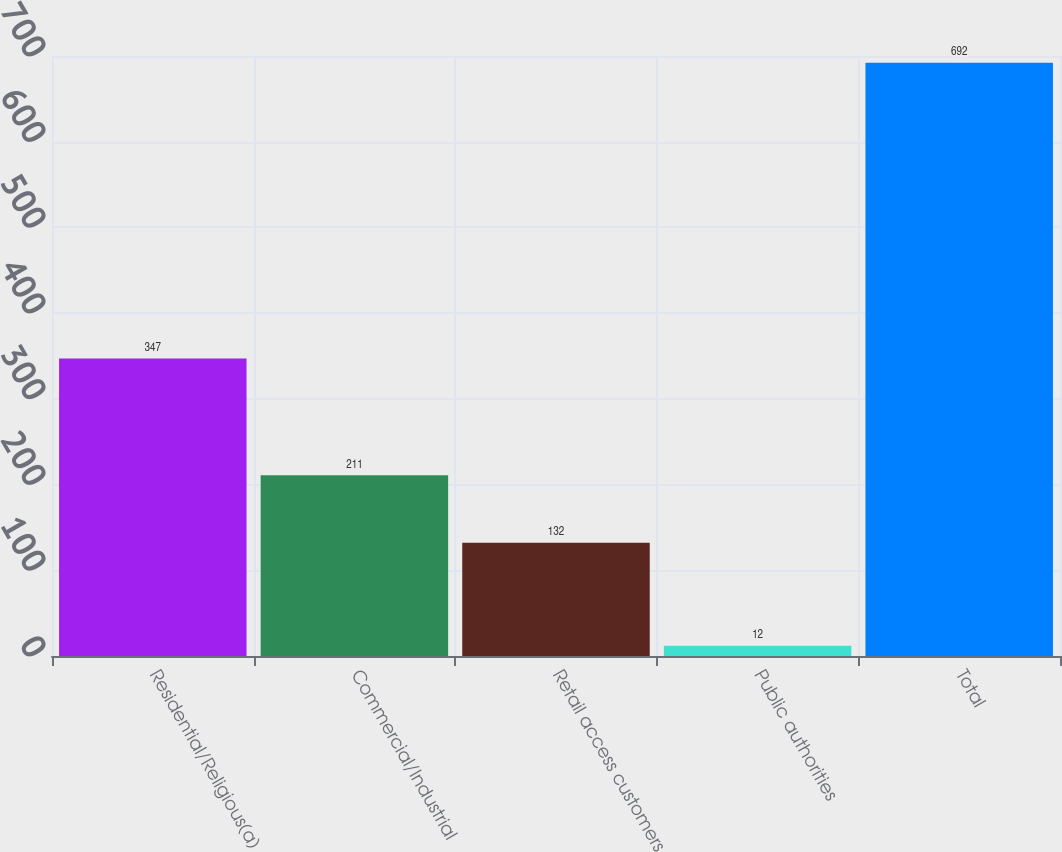<chart> <loc_0><loc_0><loc_500><loc_500><bar_chart><fcel>Residential/Religious(a)<fcel>Commercial/Industrial<fcel>Retail access customers<fcel>Public authorities<fcel>Total<nl><fcel>347<fcel>211<fcel>132<fcel>12<fcel>692<nl></chart> 